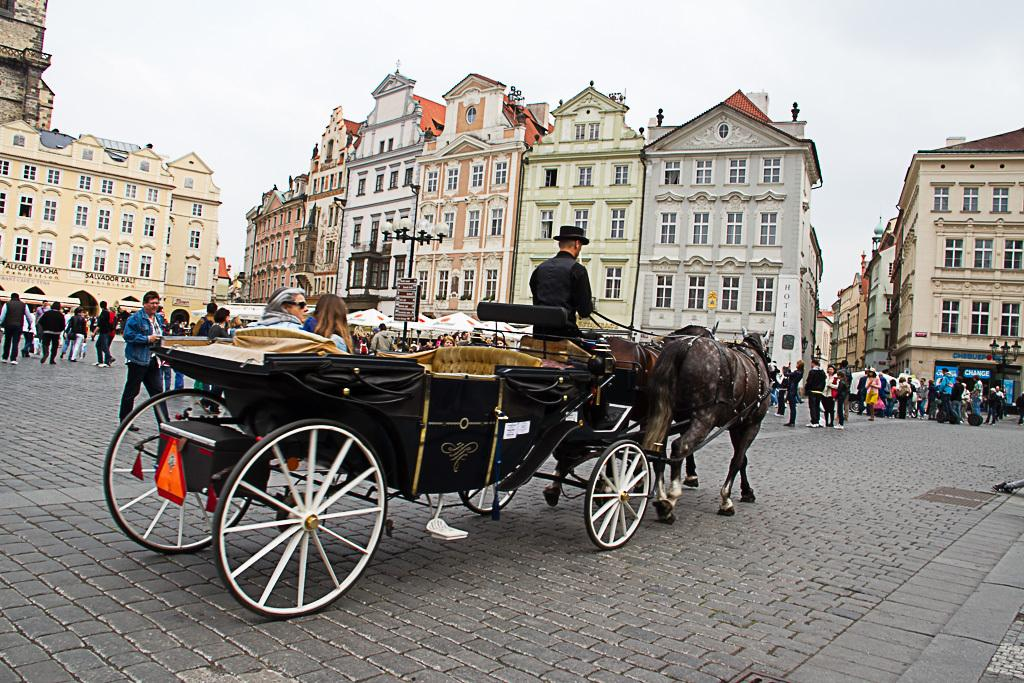What is the person in the image doing? There is a person riding a vehicle in the image. What else can be seen in the image besides the person on the vehicle? There are many people standing on the road in the image. What can be seen in the distance in the image? There are buildings in the background of the image. What is visible above the buildings in the image? The sky is visible in the background of the image. Can you tell me how many blocks of cheese are on the road in the image? There is no cheese present in the image; it features a person riding a vehicle and people standing on the road. 